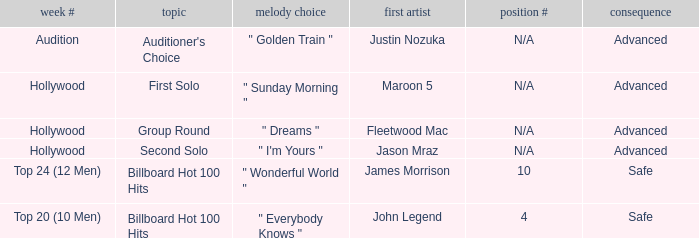What are all the effects of songs in "golden train"? Advanced. 